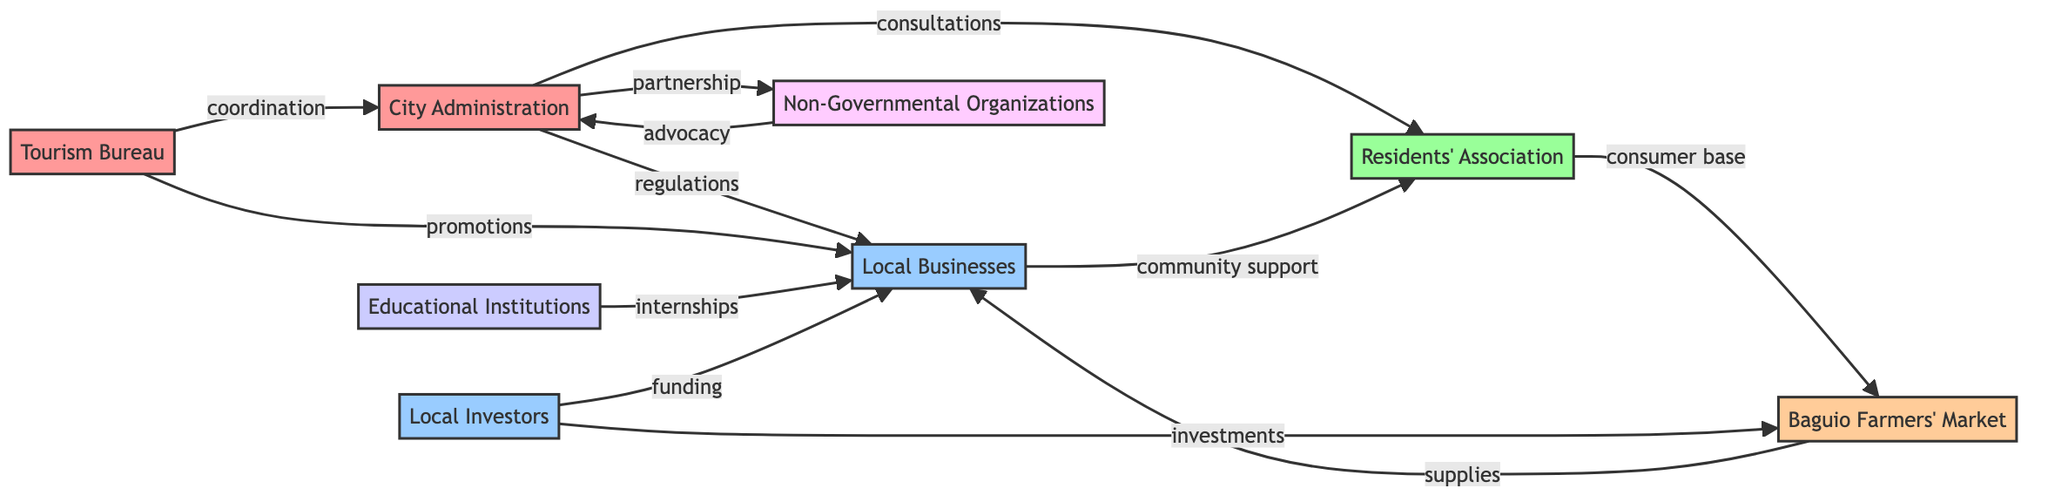What's the total number of nodes in the diagram? The diagram lists eight distinct entities involved in the local economy, which are represented as nodes. By counting each node in the provided data, I confirm there are eight nodes.
Answer: 8 What type of relationship connects the City Administration and Local Businesses? The relationship specified between the City Administration and Local Businesses is described as "regulations." This is clear from the connection shown in the diagram between these two nodes.
Answer: regulations Who are the key stakeholders that provide funding to Local Businesses? The diagram indicates that Local Investors provide funding to Local Businesses. This relationship illustrates the financial support aspect between these two stakeholders.
Answer: Local Investors How many relationships does the Residents' Association have? The Residents' Association is linked to three different entities in the diagram: City Administration, Local Businesses, and Baguio Farmers' Market. By counting the outgoing connections, I determine there are three relationships associated with this node.
Answer: 3 What connection exists between the Tourism Bureau and City Administration? The connection between the Tourism Bureau and City Administration is through the relationship termed "coordination." This suggests their collaboration or alignment in efforts regarding local tourism initiatives.
Answer: coordination What type of stakeholder is Baguio Farmers' Market classified as? In the diagram, Baguio Farmers' Market is classified specifically as a "Market." The categorization is explicitly noted in the node description provided in the data.
Answer: Market Which node receives the most interactions based on the relationships depicted? Analyzing the diagram, the Local Businesses node seems to have the highest number of interactions, linking to several other stakeholders including the City Administration, Residents' Association, Baguio Farmers' Market, Tourism Bureau, Educational Institutions, and Local Investors.
Answer: Local Businesses What role do Non-Governmental Organizations play in relation to the City Administration? Non-Governmental Organizations have a relationship with the City Administration characterized as "advocacy." This indicates that NGOs seek to influence or support the city's governance or policies.
Answer: advocacy What is the relationship between Local Investors and Baguio Farmers' Market? The relationship between Local Investors and Baguio Farmers' Market is defined as "investments." This indicates that Local Investors are involved in funding or enhancing the farmers' market operations.
Answer: investments 